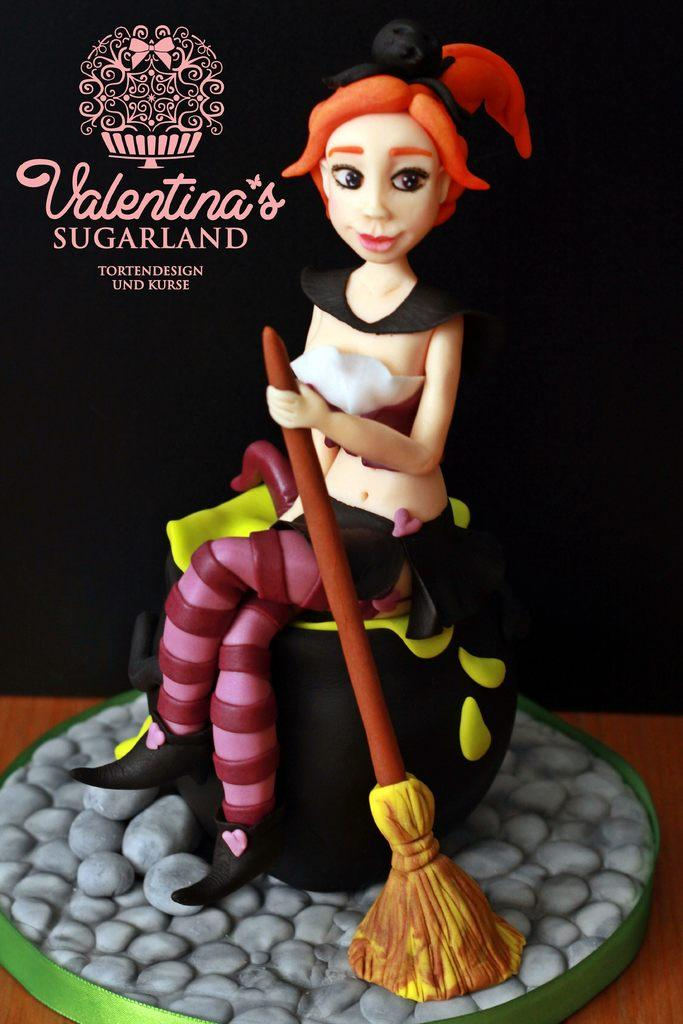What type of visual is depicted in the image? The image is a poster. What is the main subject of the poster? There is a doll on the surface of the poster. Are there any words or phrases on the poster? Yes, there is text on the poster. What is the color of the background in the poster? The background of the poster is dark. What type of lunch is being served in the hall depicted in the image? There is no hall or lunch depicted in the image; it is a poster featuring a doll with text and a dark background. 